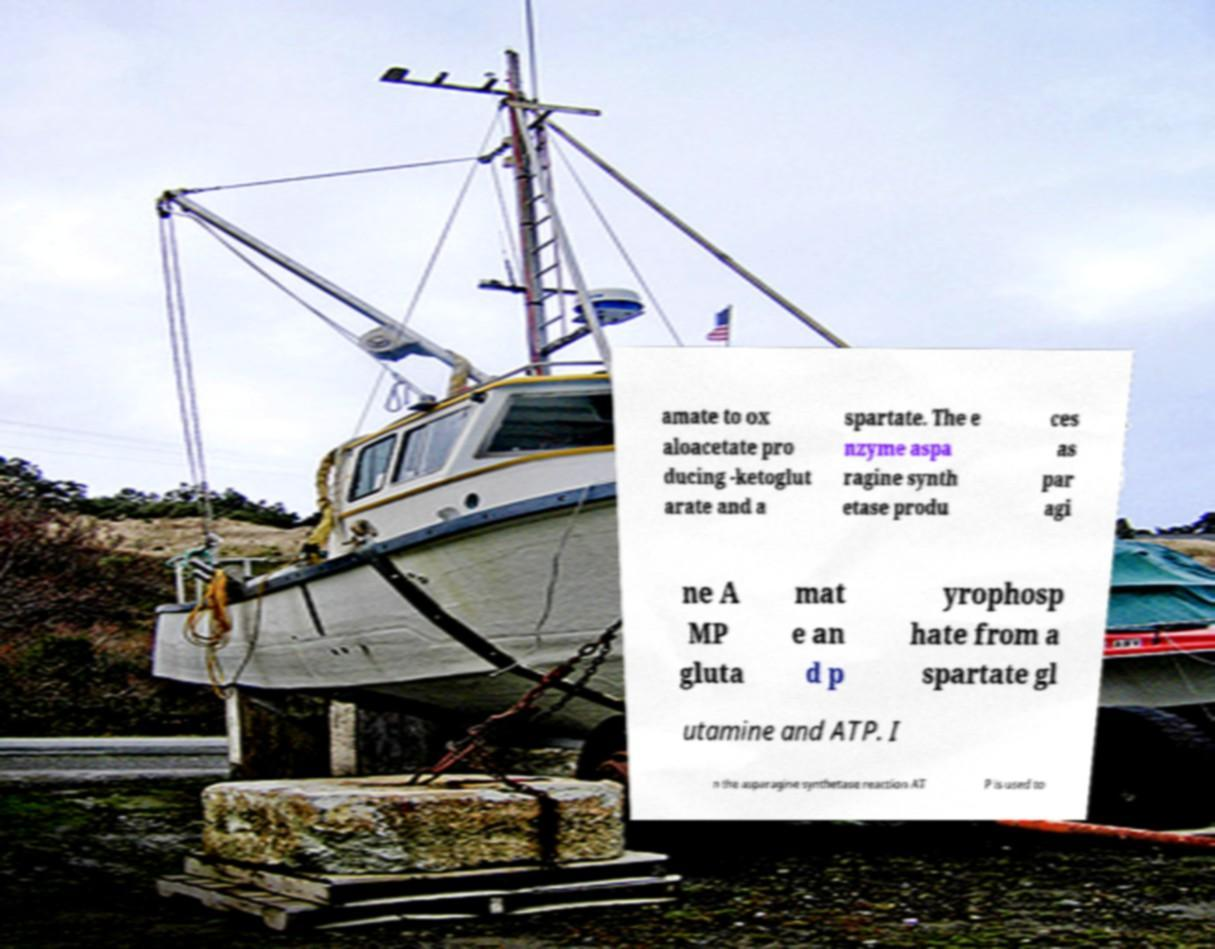Please identify and transcribe the text found in this image. amate to ox aloacetate pro ducing -ketoglut arate and a spartate. The e nzyme aspa ragine synth etase produ ces as par agi ne A MP gluta mat e an d p yrophosp hate from a spartate gl utamine and ATP. I n the asparagine synthetase reaction AT P is used to 